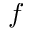Convert formula to latex. <formula><loc_0><loc_0><loc_500><loc_500>f</formula> 